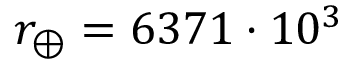Convert formula to latex. <formula><loc_0><loc_0><loc_500><loc_500>r _ { \oplus } = 6 3 7 1 \cdot 1 0 ^ { 3 }</formula> 